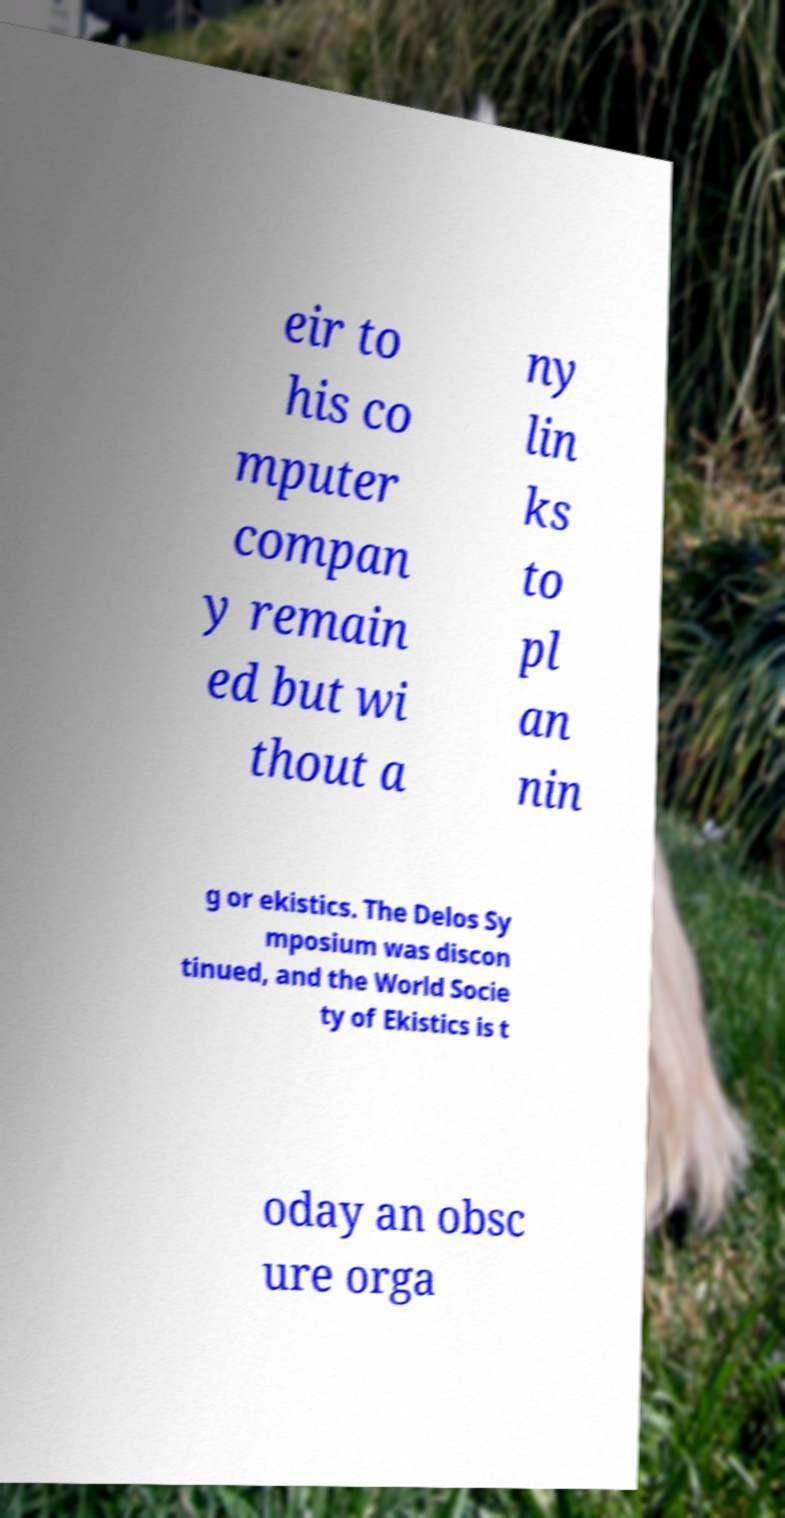Could you assist in decoding the text presented in this image and type it out clearly? eir to his co mputer compan y remain ed but wi thout a ny lin ks to pl an nin g or ekistics. The Delos Sy mposium was discon tinued, and the World Socie ty of Ekistics is t oday an obsc ure orga 